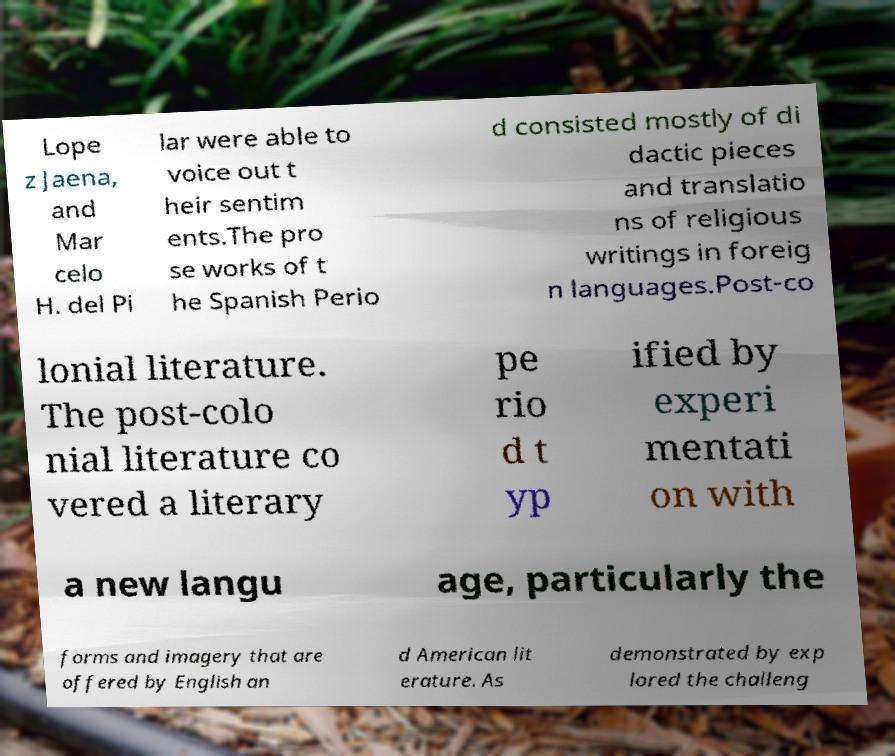Could you assist in decoding the text presented in this image and type it out clearly? Lope z Jaena, and Mar celo H. del Pi lar were able to voice out t heir sentim ents.The pro se works of t he Spanish Perio d consisted mostly of di dactic pieces and translatio ns of religious writings in foreig n languages.Post-co lonial literature. The post-colo nial literature co vered a literary pe rio d t yp ified by experi mentati on with a new langu age, particularly the forms and imagery that are offered by English an d American lit erature. As demonstrated by exp lored the challeng 